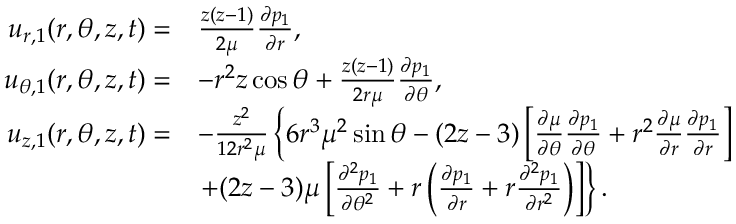<formula> <loc_0><loc_0><loc_500><loc_500>\begin{array} { r l } { u _ { r , 1 } ( r , \theta , z , t ) = } & { \frac { z ( z - 1 ) } { 2 \mu } \frac { \partial p _ { 1 } } { \partial r } , } \\ { u _ { \theta , 1 } ( r , \theta , z , t ) = } & { - r ^ { 2 } z \cos \theta + \frac { z ( z - 1 ) } { 2 r \mu } \frac { \partial p _ { 1 } } { \partial \theta } , } \\ { u _ { z , 1 } ( r , \theta , z , t ) = } & { - \frac { z ^ { 2 } } { 1 2 r ^ { 2 } \mu } \left \{ 6 r ^ { 3 } \mu ^ { 2 } \sin \theta - ( 2 z - 3 ) \left [ \frac { \partial \mu } { \partial \theta } \frac { \partial p _ { 1 } } { \partial \theta } + r ^ { 2 } \frac { \partial \mu } { \partial r } \frac { \partial p _ { 1 } } { \partial r } \right ] } \\ & { + ( 2 z - 3 ) \mu \left [ \frac { \partial ^ { 2 } p _ { 1 } } { \partial \theta ^ { 2 } } + r \left ( \frac { \partial p _ { 1 } } { \partial r } + r \frac { \partial ^ { 2 } p _ { 1 } } { \partial r ^ { 2 } } \right ) \right ] \right \} . } \end{array}</formula> 